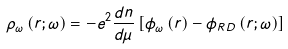<formula> <loc_0><loc_0><loc_500><loc_500>\rho _ { \omega } \left ( { r } ; \omega \right ) = - e ^ { 2 } \frac { d n } { d \mu } \left [ \phi _ { \omega } \left ( { r } \right ) - \phi _ { R D } \left ( { r } ; \omega \right ) \right ]</formula> 